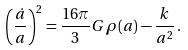Convert formula to latex. <formula><loc_0><loc_0><loc_500><loc_500>\left ( \frac { \dot { a } } { a } \right ) ^ { 2 } = \frac { 1 6 \pi } { 3 } G \, \rho ( a ) - \frac { k } { a ^ { 2 } } \, .</formula> 